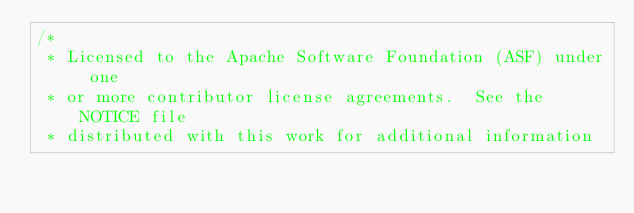Convert code to text. <code><loc_0><loc_0><loc_500><loc_500><_Java_>/*
 * Licensed to the Apache Software Foundation (ASF) under one
 * or more contributor license agreements.  See the NOTICE file
 * distributed with this work for additional information</code> 